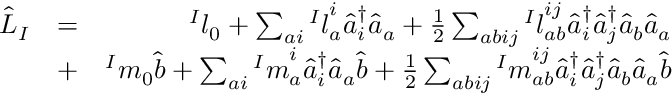Convert formula to latex. <formula><loc_0><loc_0><loc_500><loc_500>\begin{array} { r l r } { \hat { L } _ { I } } & { = } & { { ^ { I } l } _ { 0 } + \sum _ { a i } { ^ { I } l } _ { a } ^ { i } \hat { a } _ { i } ^ { \dagger } \hat { a } _ { a } + \frac { 1 } { 2 } \sum _ { a b i j } { ^ { I } l } _ { a b } ^ { i j } \hat { a } _ { i } ^ { \dagger } \hat { a } _ { j } ^ { \dagger } \hat { a } _ { b } \hat { a } _ { a } } \\ & { + } & { { ^ { I } m } _ { 0 } \hat { b } + \sum _ { a i } { ^ { I } m } _ { a } ^ { i } \hat { a } _ { i } ^ { \dagger } \hat { a } _ { a } \hat { b } + \frac { 1 } { 2 } \sum _ { a b i j } { ^ { I } m } _ { a b } ^ { i j } \hat { a } _ { i } ^ { \dagger } \hat { a } _ { j } ^ { \dagger } \hat { a } _ { b } \hat { a } _ { a } \hat { b } } \end{array}</formula> 